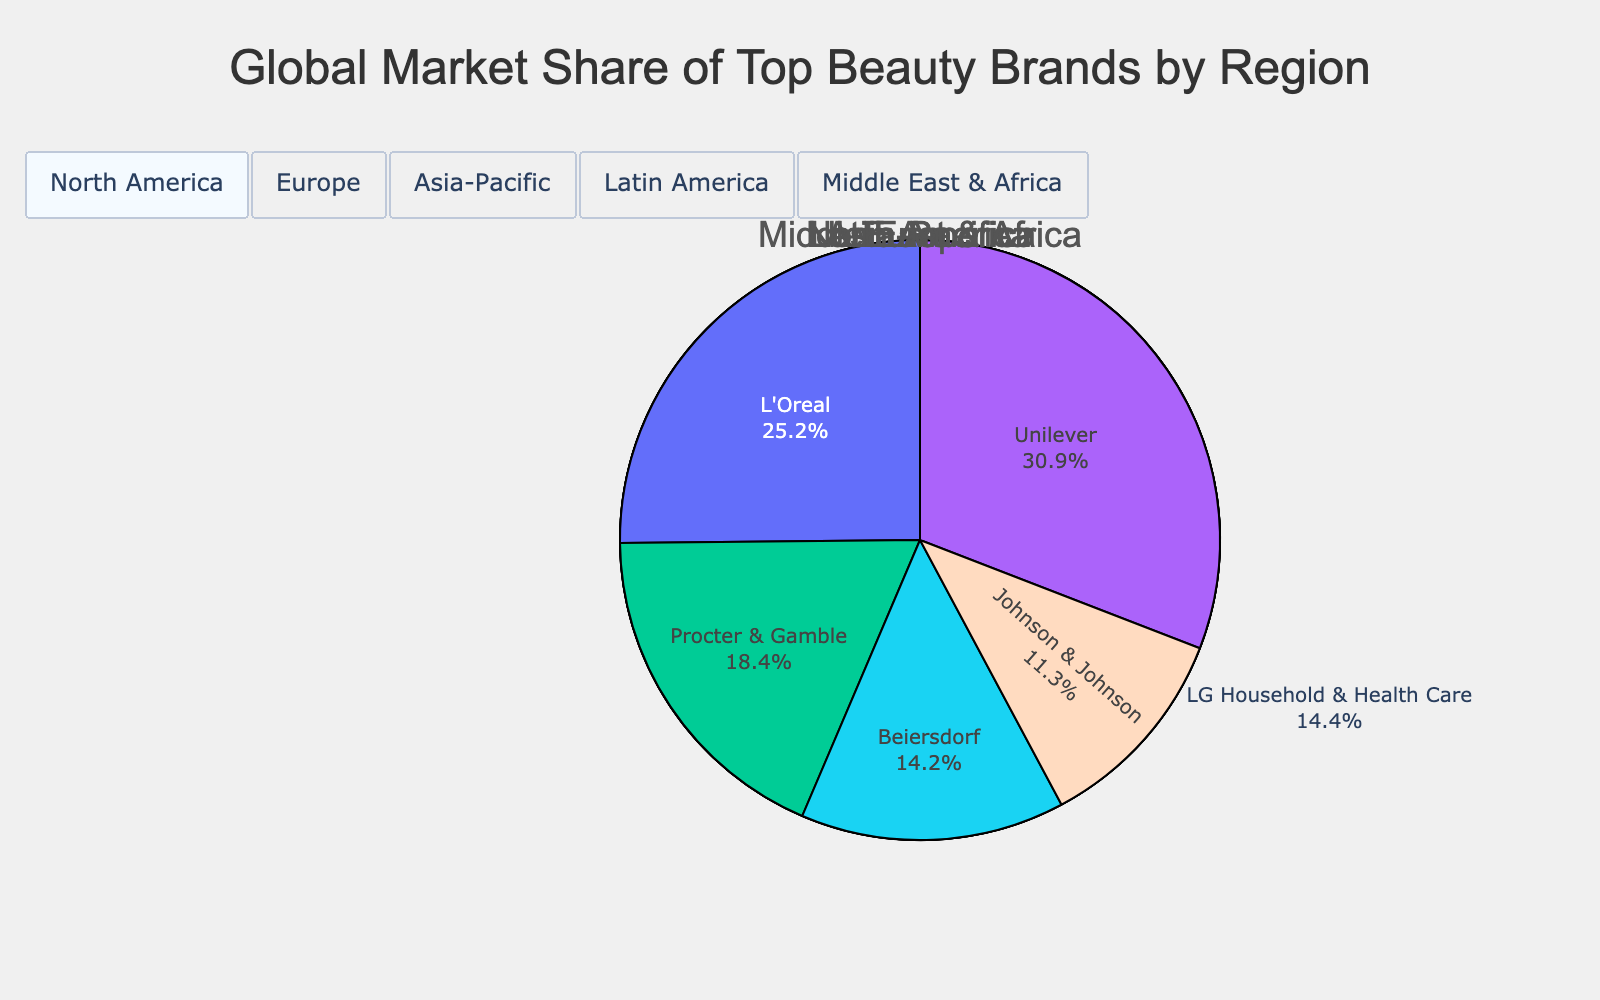What's the market share of L'Oreal in Europe? L'Oreal's market share in Europe is directly shown on the pie chart, which would be the segment labeled "L'Oreal" in the Europe section.
Answer: 22.3% Which brand has the highest market share in the Middle East & Africa? By visually inspecting the Middle East & Africa section of the pie chart, identify the largest segment which represents the highest market share. The label of the largest segment is the answer.
Answer: Unilever What is the combined market share of L'Oreal in all regions? Sum up the market share of L'Oreal in North America (18.5%), Europe (22.3%), Asia-Pacific (14.2%), Latin America (18.9%), and Middle East & Africa (19.8%). The combined market share is 18.5 + 22.3 + 14.2 + 18.9 + 19.8 = 93.7%.
Answer: 93.7% Which region does Estee Lauder have its highest market share, and what is the percentage? Compare Estee Lauder's market share across different regions. Identify the region where Estee Lauder has the highest market share and note the percentage. Estee Lauder's market shares are: North America (15.2%), Asia-Pacific (12.8%). The highest is in North America with 15.2%.
Answer: North America, 15.2% Between North America and Latin America, which has a higher market share for Unilever, and by how much? Identify Unilever's market share in North America (10.5%) and in Latin America (15.7%). Subtract the smaller share from the larger share to find the difference. 15.7% - 10.5% = 5.2%.
Answer: Latin America, 5.2% What is the total market share of the top three brands in the Asia-Pacific region? The top three brands in the Asia-Pacific region are Shiseido (19.7%), AmorePacific (16.4%), and L'Oreal (14.2%). Sum these percentages to get the total market share: 19.7 + 16.4 + 14.2 = 50.3%.
Answer: 50.3% Which brand has the smallest market share in Europe, and what is that percentage? Visually inspect the pie chart for the Europe region and identify the smallest segment. The label along with its percentage represents the answer. The smallest segment in Europe is Chanel at 9.5%.
Answer: Chanel, 9.5% How does the market share of Procter & Gamble in the Middle East & Africa compare to its market share in North America? Find Procter & Gamble's market share in the Middle East & Africa (14.5%) and in North America (12.8%). Compare these two values to determine which is larger. 14.5% is larger than 12.8%.
Answer: Middle East & Africa has a higher share What is the average market share of the top two brands in each region? Calculate the average for each region's top two brands:
    - North America: L'Oreal (18.5%) and Estee Lauder (15.2%); average = (18.5 + 15.2) / 2 = 16.85%
    - Europe: L'Oreal (22.3%) and Beiersdorf (14.6%); average = (22.3 + 14.6) / 2 = 18.45%
    - Asia-Pacific: Shiseido (19.7%) and AmorePacific (16.4%); average = (19.7 + 16.4) / 2 = 18.05%
    - Latin America: Natura &Co (21.5%) and L'Oreal (18.9%); average = (21.5 + 18.9) / 2 = 20.2%
    - Middle East & Africa: Unilever (24.3%) and L'Oreal (19.8%); average = (24.3 + 19.8) / 2 = 22.05%
Answer: 16.85%, 18.45%, 18.05%, 20.2%, 22.05% 